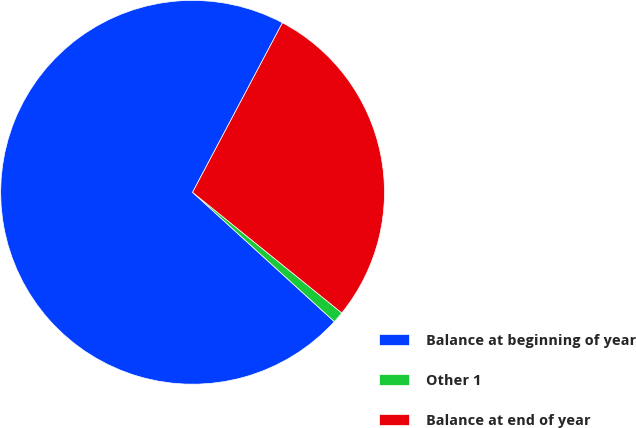Convert chart. <chart><loc_0><loc_0><loc_500><loc_500><pie_chart><fcel>Balance at beginning of year<fcel>Other 1<fcel>Balance at end of year<nl><fcel>70.99%<fcel>0.95%<fcel>28.06%<nl></chart> 